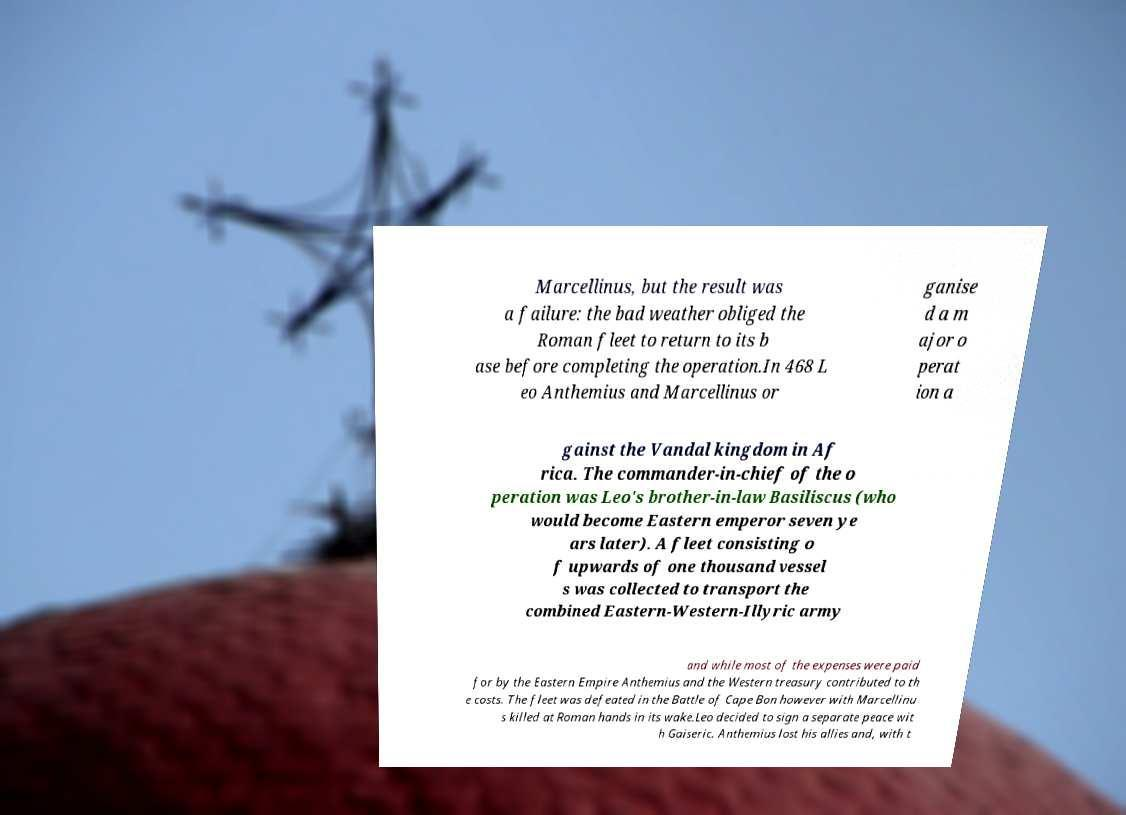Can you accurately transcribe the text from the provided image for me? Marcellinus, but the result was a failure: the bad weather obliged the Roman fleet to return to its b ase before completing the operation.In 468 L eo Anthemius and Marcellinus or ganise d a m ajor o perat ion a gainst the Vandal kingdom in Af rica. The commander-in-chief of the o peration was Leo's brother-in-law Basiliscus (who would become Eastern emperor seven ye ars later). A fleet consisting o f upwards of one thousand vessel s was collected to transport the combined Eastern-Western-Illyric army and while most of the expenses were paid for by the Eastern Empire Anthemius and the Western treasury contributed to th e costs. The fleet was defeated in the Battle of Cape Bon however with Marcellinu s killed at Roman hands in its wake.Leo decided to sign a separate peace wit h Gaiseric. Anthemius lost his allies and, with t 